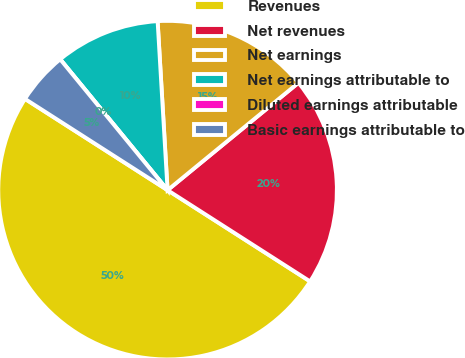<chart> <loc_0><loc_0><loc_500><loc_500><pie_chart><fcel>Revenues<fcel>Net revenues<fcel>Net earnings<fcel>Net earnings attributable to<fcel>Diluted earnings attributable<fcel>Basic earnings attributable to<nl><fcel>50.0%<fcel>20.0%<fcel>15.0%<fcel>10.0%<fcel>0.0%<fcel>5.0%<nl></chart> 